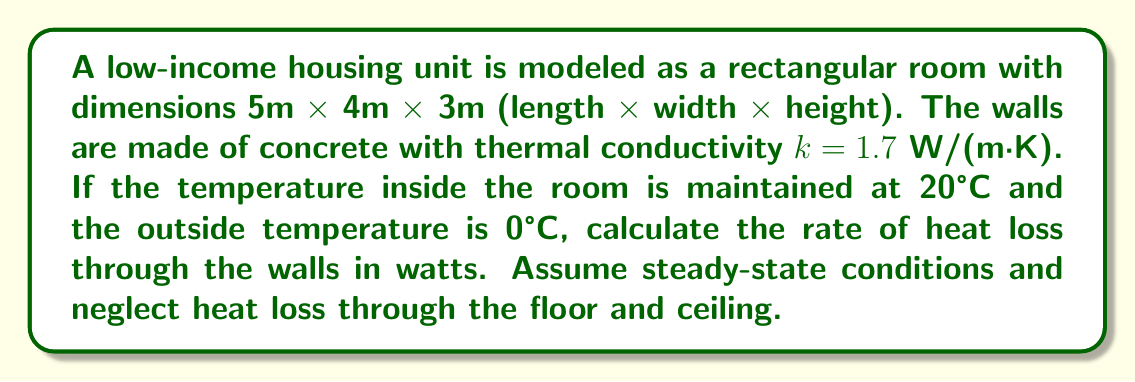Provide a solution to this math problem. To solve this problem, we'll use Fourier's law of heat conduction in one dimension:

$$ Q = -kA\frac{dT}{dx} $$

Where:
$Q$ = rate of heat transfer (W)
$k$ = thermal conductivity (W/(m·K))
$A$ = surface area (m²)
$\frac{dT}{dx}$ = temperature gradient (K/m)

Steps:
1) Calculate the total surface area of the walls:
   $A = 2(5 \times 3) + 2(4 \times 3) = 30 + 24 = 54 \text{ m}^2$

2) The temperature difference is:
   $\Delta T = 20°C - 0°C = 20 \text{ K}$

3) The thickness of the walls isn't given, so we'll assume a typical value of 0.2 m.
   The temperature gradient is:
   $\frac{dT}{dx} = \frac{\Delta T}{\text{thickness}} = \frac{20 \text{ K}}{0.2 \text{ m}} = 100 \text{ K/m}$

4) Now we can apply Fourier's law:
   $Q = -k A \frac{dT}{dx}$
   $Q = -1.7 \times 54 \times 100 = -9180 \text{ W}$

5) The negative sign indicates heat flow from inside to outside. We're interested in the magnitude, so:
   $Q = 9180 \text{ W}$
Answer: 9180 W 